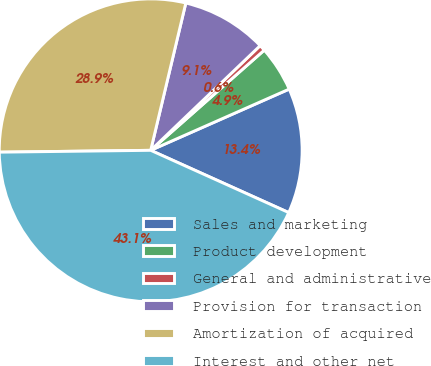<chart> <loc_0><loc_0><loc_500><loc_500><pie_chart><fcel>Sales and marketing<fcel>Product development<fcel>General and administrative<fcel>Provision for transaction<fcel>Amortization of acquired<fcel>Interest and other net<nl><fcel>13.37%<fcel>4.88%<fcel>0.64%<fcel>9.13%<fcel>28.92%<fcel>43.06%<nl></chart> 